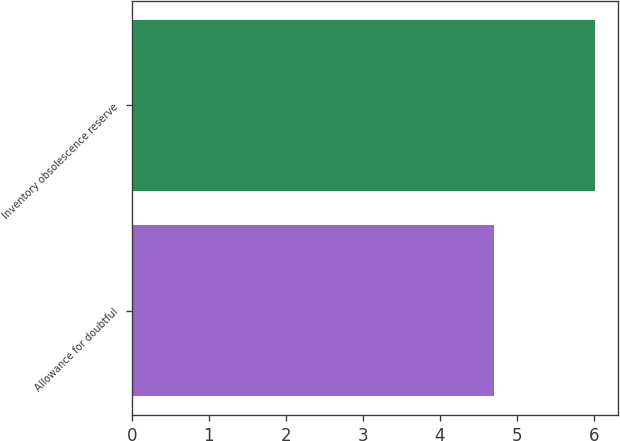Convert chart. <chart><loc_0><loc_0><loc_500><loc_500><bar_chart><fcel>Allowance for doubtful<fcel>Inventory obsolescence reserve<nl><fcel>4.71<fcel>6.02<nl></chart> 